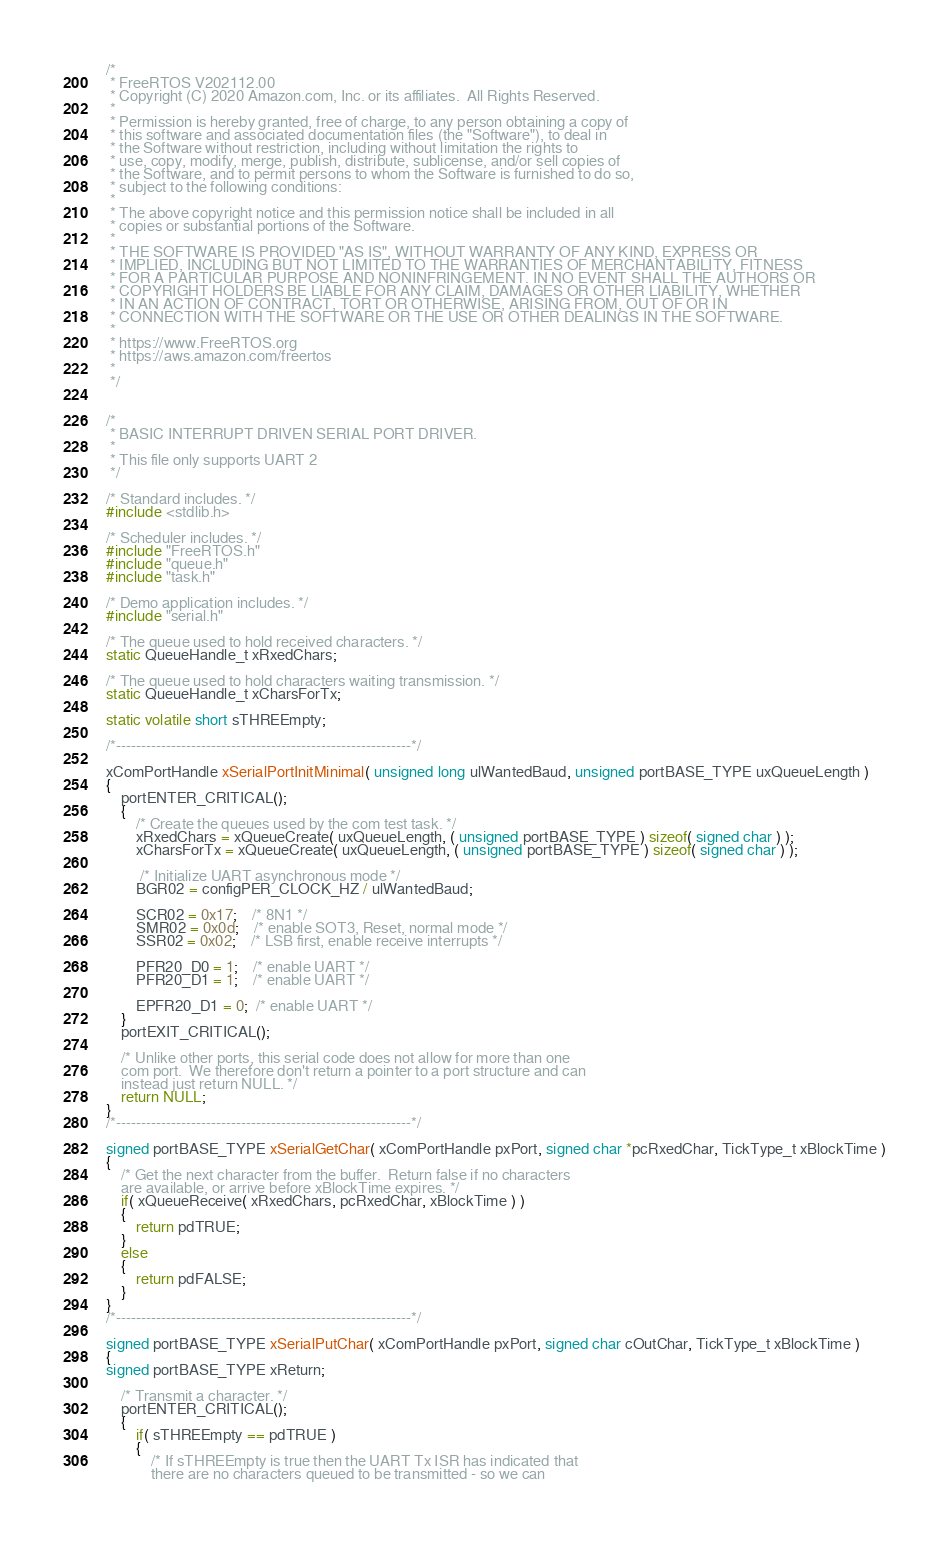Convert code to text. <code><loc_0><loc_0><loc_500><loc_500><_C_>/*
 * FreeRTOS V202112.00
 * Copyright (C) 2020 Amazon.com, Inc. or its affiliates.  All Rights Reserved.
 *
 * Permission is hereby granted, free of charge, to any person obtaining a copy of
 * this software and associated documentation files (the "Software"), to deal in
 * the Software without restriction, including without limitation the rights to
 * use, copy, modify, merge, publish, distribute, sublicense, and/or sell copies of
 * the Software, and to permit persons to whom the Software is furnished to do so,
 * subject to the following conditions:
 *
 * The above copyright notice and this permission notice shall be included in all
 * copies or substantial portions of the Software.
 *
 * THE SOFTWARE IS PROVIDED "AS IS", WITHOUT WARRANTY OF ANY KIND, EXPRESS OR
 * IMPLIED, INCLUDING BUT NOT LIMITED TO THE WARRANTIES OF MERCHANTABILITY, FITNESS
 * FOR A PARTICULAR PURPOSE AND NONINFRINGEMENT. IN NO EVENT SHALL THE AUTHORS OR
 * COPYRIGHT HOLDERS BE LIABLE FOR ANY CLAIM, DAMAGES OR OTHER LIABILITY, WHETHER
 * IN AN ACTION OF CONTRACT, TORT OR OTHERWISE, ARISING FROM, OUT OF OR IN
 * CONNECTION WITH THE SOFTWARE OR THE USE OR OTHER DEALINGS IN THE SOFTWARE.
 *
 * https://www.FreeRTOS.org
 * https://aws.amazon.com/freertos
 *
 */


/* 
 * BASIC INTERRUPT DRIVEN SERIAL PORT DRIVER.   
 * 
 * This file only supports UART 2
 */

/* Standard includes. */
#include <stdlib.h>

/* Scheduler includes. */
#include "FreeRTOS.h"
#include "queue.h"
#include "task.h"

/* Demo application includes. */
#include "serial.h"

/* The queue used to hold received characters. */
static QueueHandle_t xRxedChars; 

/* The queue used to hold characters waiting transmission. */
static QueueHandle_t xCharsForTx; 

static volatile short sTHREEmpty;

/*-----------------------------------------------------------*/

xComPortHandle xSerialPortInitMinimal( unsigned long ulWantedBaud, unsigned portBASE_TYPE uxQueueLength )
{
	portENTER_CRITICAL();
	{
		/* Create the queues used by the com test task. */
		xRxedChars = xQueueCreate( uxQueueLength, ( unsigned portBASE_TYPE ) sizeof( signed char ) );
		xCharsForTx = xQueueCreate( uxQueueLength, ( unsigned portBASE_TYPE ) sizeof( signed char ) );

		 /* Initialize UART asynchronous mode */
		BGR02 = configPER_CLOCK_HZ / ulWantedBaud;
		  
		SCR02 = 0x17;	/* 8N1 */
		SMR02 = 0x0d;	/* enable SOT3, Reset, normal mode */
		SSR02 = 0x02;	/* LSB first, enable receive interrupts */

		PFR20_D0 = 1;	/* enable UART */
		PFR20_D1 = 1;	/* enable UART */

		EPFR20_D1 = 0;  /* enable UART */
	}
	portEXIT_CRITICAL();
	
	/* Unlike other ports, this serial code does not allow for more than one
	com port.  We therefore don't return a pointer to a port structure and can
	instead just return NULL. */
	return NULL;
}
/*-----------------------------------------------------------*/

signed portBASE_TYPE xSerialGetChar( xComPortHandle pxPort, signed char *pcRxedChar, TickType_t xBlockTime )
{
	/* Get the next character from the buffer.  Return false if no characters
	are available, or arrive before xBlockTime expires. */
	if( xQueueReceive( xRxedChars, pcRxedChar, xBlockTime ) )
	{
		return pdTRUE;
	}
	else
	{
		return pdFALSE;
	}
}
/*-----------------------------------------------------------*/

signed portBASE_TYPE xSerialPutChar( xComPortHandle pxPort, signed char cOutChar, TickType_t xBlockTime )
{
signed portBASE_TYPE xReturn;

	/* Transmit a character. */
	portENTER_CRITICAL();
	{
		if( sTHREEmpty == pdTRUE )
		{
			/* If sTHREEmpty is true then the UART Tx ISR has indicated that 
			there are no characters queued to be transmitted - so we can</code> 